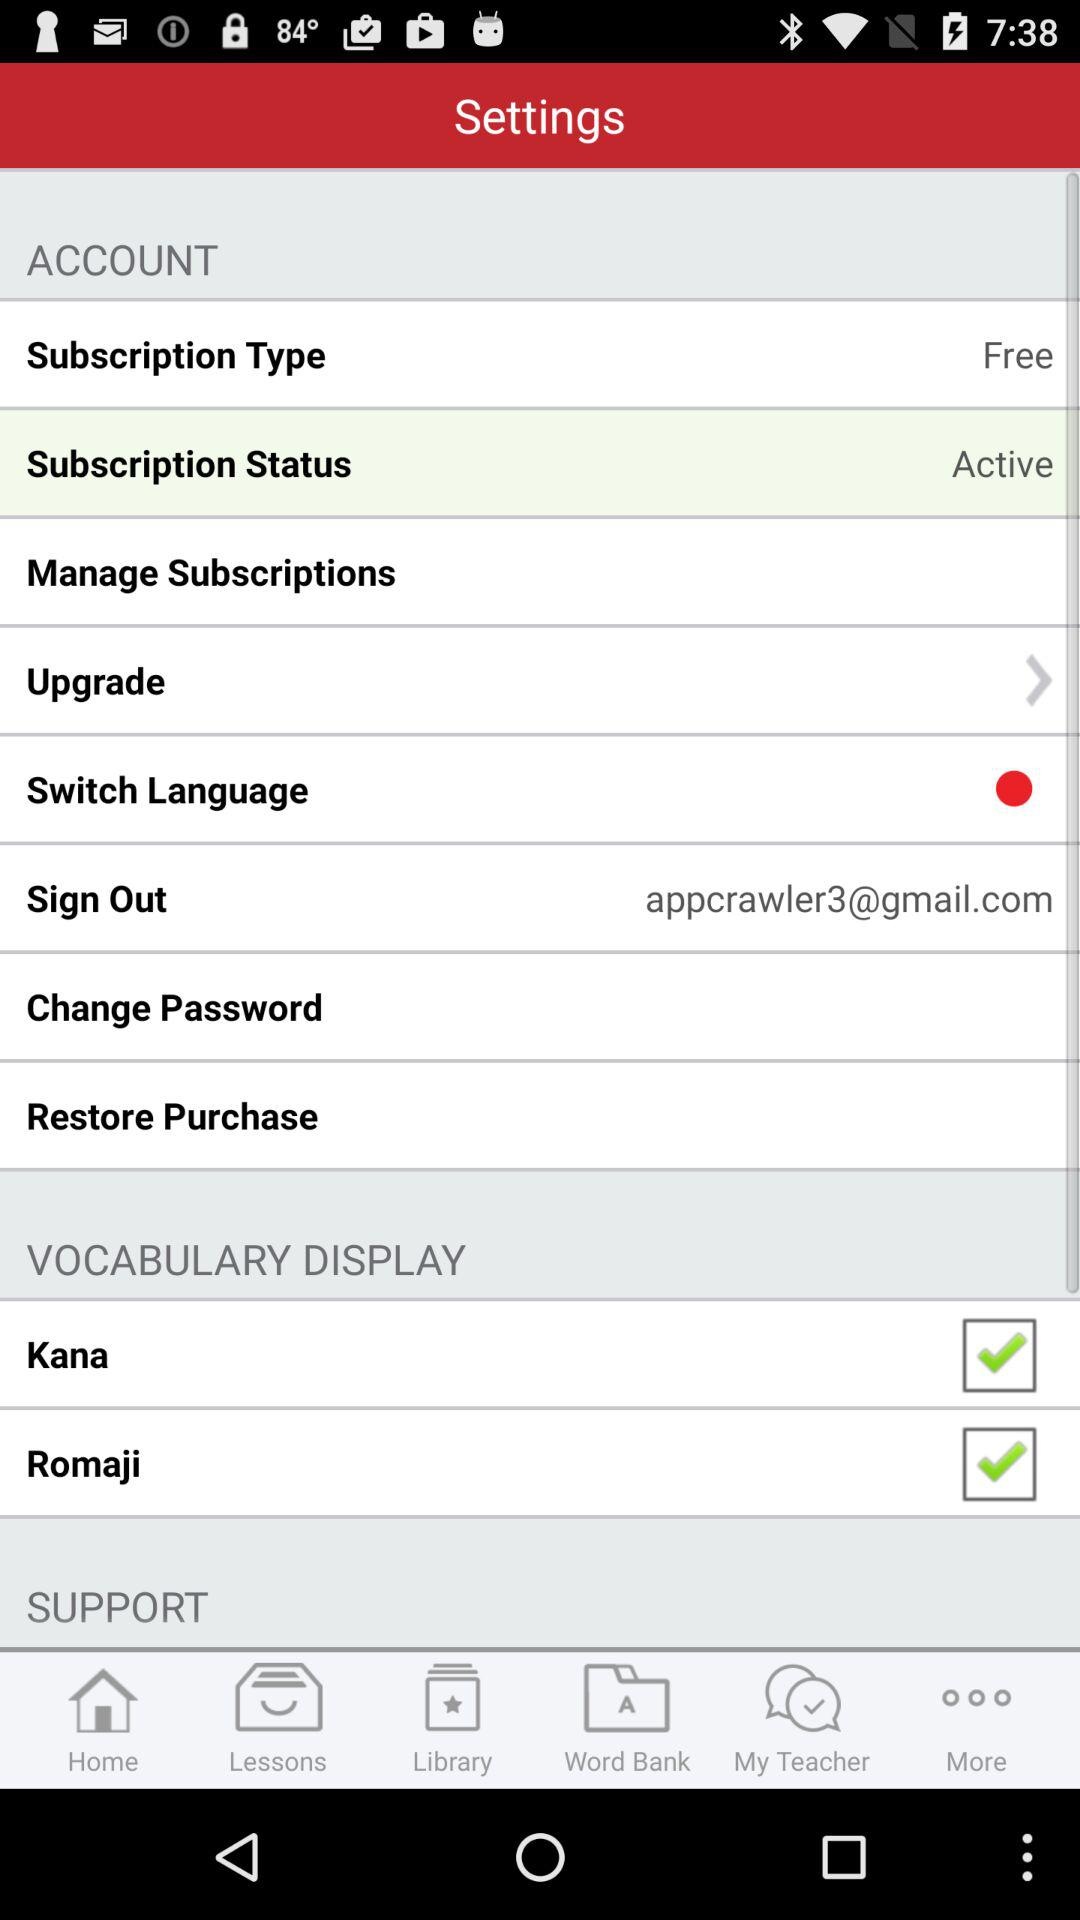How many items are in the Vocabulary Display section?
Answer the question using a single word or phrase. 2 